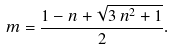Convert formula to latex. <formula><loc_0><loc_0><loc_500><loc_500>m = \frac { 1 - n + \sqrt { 3 \, n ^ { 2 } + 1 } } { 2 } .</formula> 